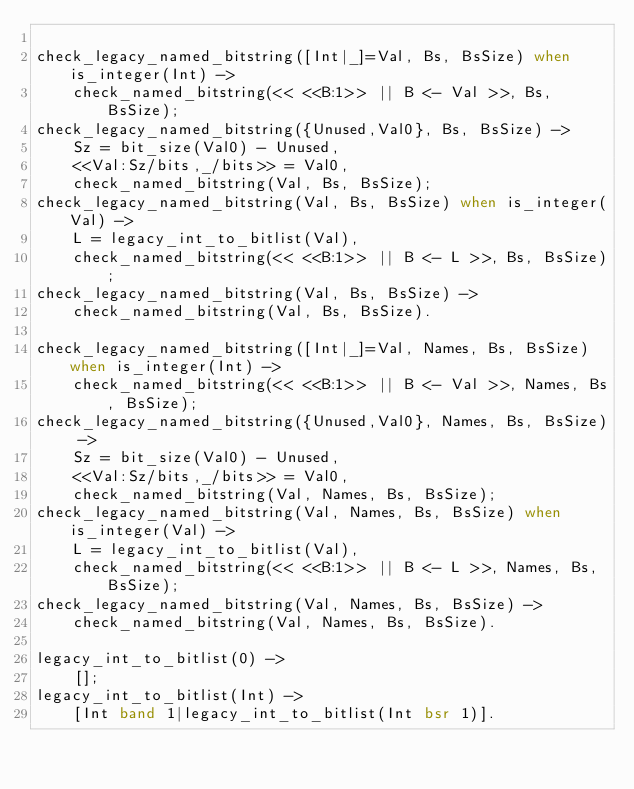Convert code to text. <code><loc_0><loc_0><loc_500><loc_500><_Erlang_>
check_legacy_named_bitstring([Int|_]=Val, Bs, BsSize) when is_integer(Int) ->
    check_named_bitstring(<< <<B:1>> || B <- Val >>, Bs, BsSize);
check_legacy_named_bitstring({Unused,Val0}, Bs, BsSize) ->
    Sz = bit_size(Val0) - Unused,
    <<Val:Sz/bits,_/bits>> = Val0,
    check_named_bitstring(Val, Bs, BsSize);
check_legacy_named_bitstring(Val, Bs, BsSize) when is_integer(Val) ->
    L = legacy_int_to_bitlist(Val),
    check_named_bitstring(<< <<B:1>> || B <- L >>, Bs, BsSize);
check_legacy_named_bitstring(Val, Bs, BsSize) ->
    check_named_bitstring(Val, Bs, BsSize).

check_legacy_named_bitstring([Int|_]=Val, Names, Bs, BsSize) when is_integer(Int) ->
    check_named_bitstring(<< <<B:1>> || B <- Val >>, Names, Bs, BsSize);
check_legacy_named_bitstring({Unused,Val0}, Names, Bs, BsSize) ->
    Sz = bit_size(Val0) - Unused,
    <<Val:Sz/bits,_/bits>> = Val0,
    check_named_bitstring(Val, Names, Bs, BsSize);
check_legacy_named_bitstring(Val, Names, Bs, BsSize) when is_integer(Val) ->
    L = legacy_int_to_bitlist(Val),
    check_named_bitstring(<< <<B:1>> || B <- L >>, Names, Bs, BsSize);
check_legacy_named_bitstring(Val, Names, Bs, BsSize) ->
    check_named_bitstring(Val, Names, Bs, BsSize).

legacy_int_to_bitlist(0) ->
    [];
legacy_int_to_bitlist(Int) ->
    [Int band 1|legacy_int_to_bitlist(Int bsr 1)].
</code> 